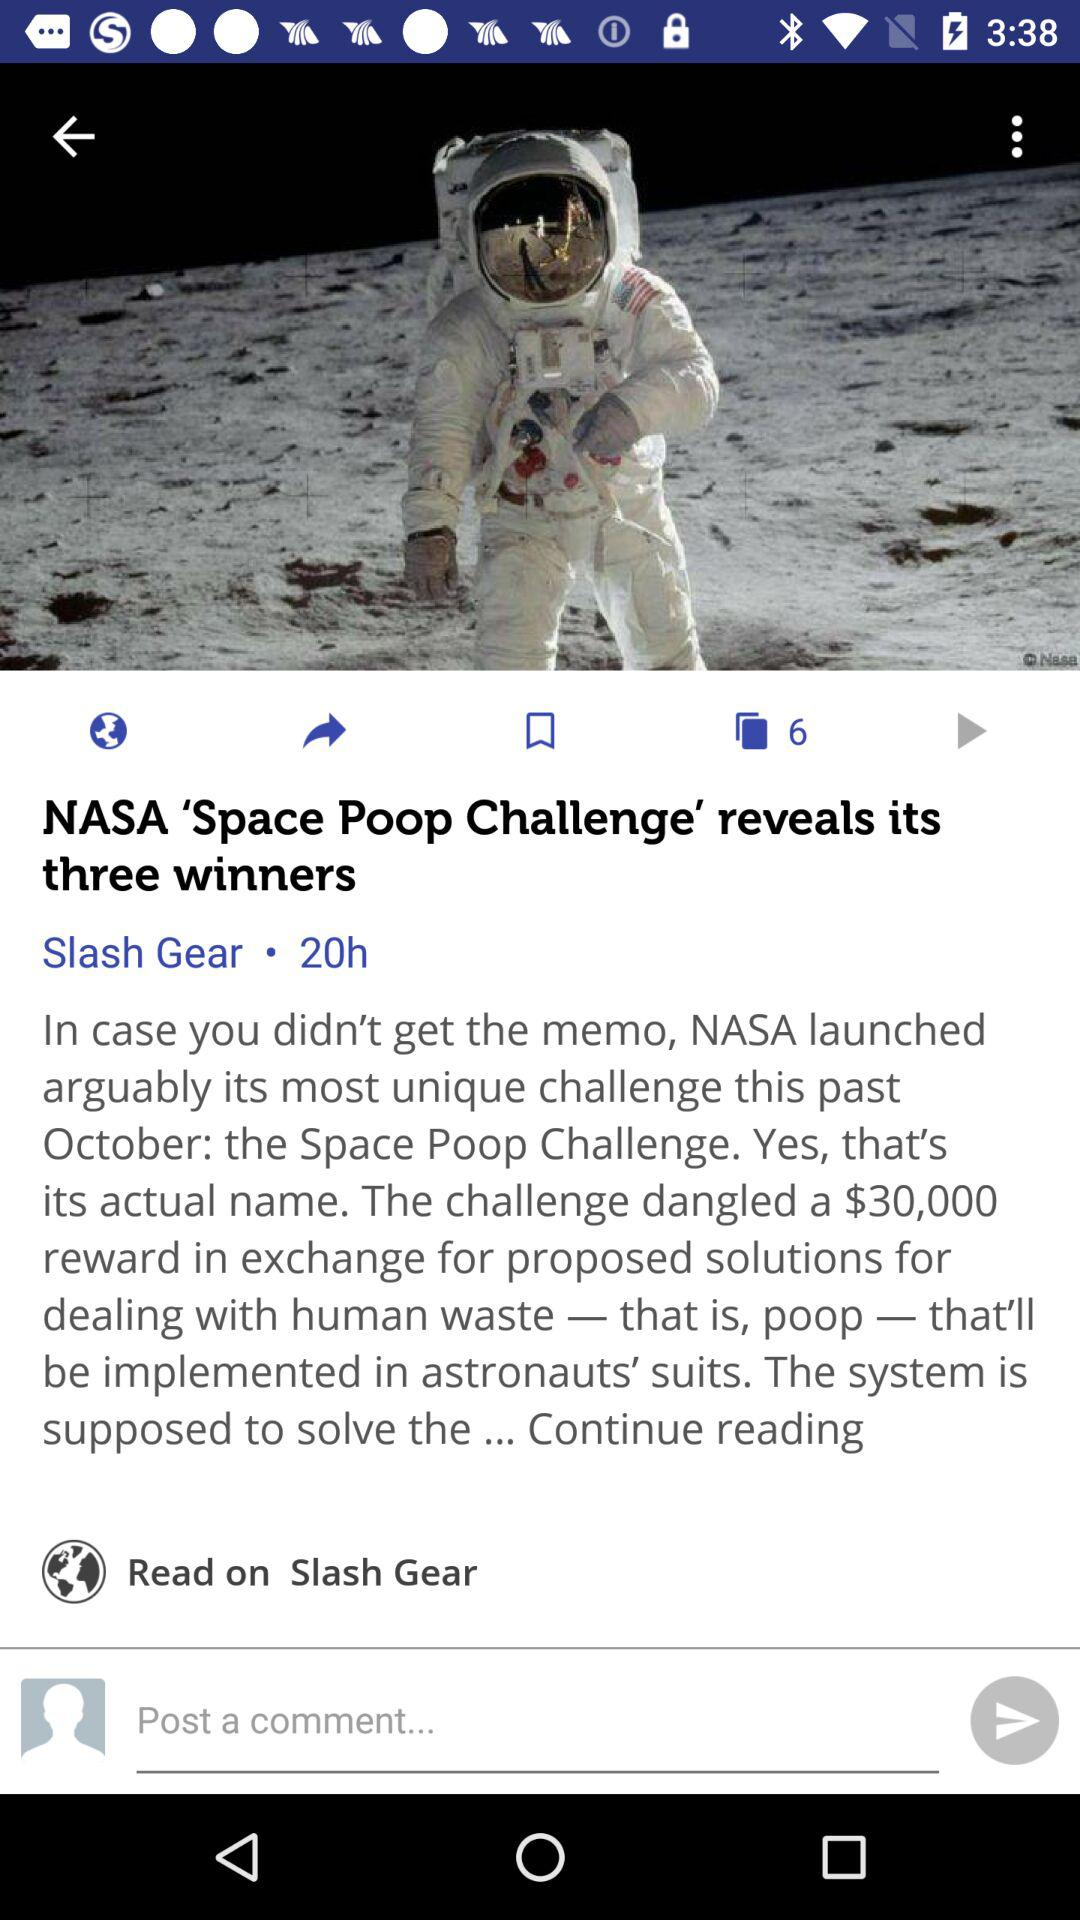What is the reward amount? The reward amount is $30,000. 